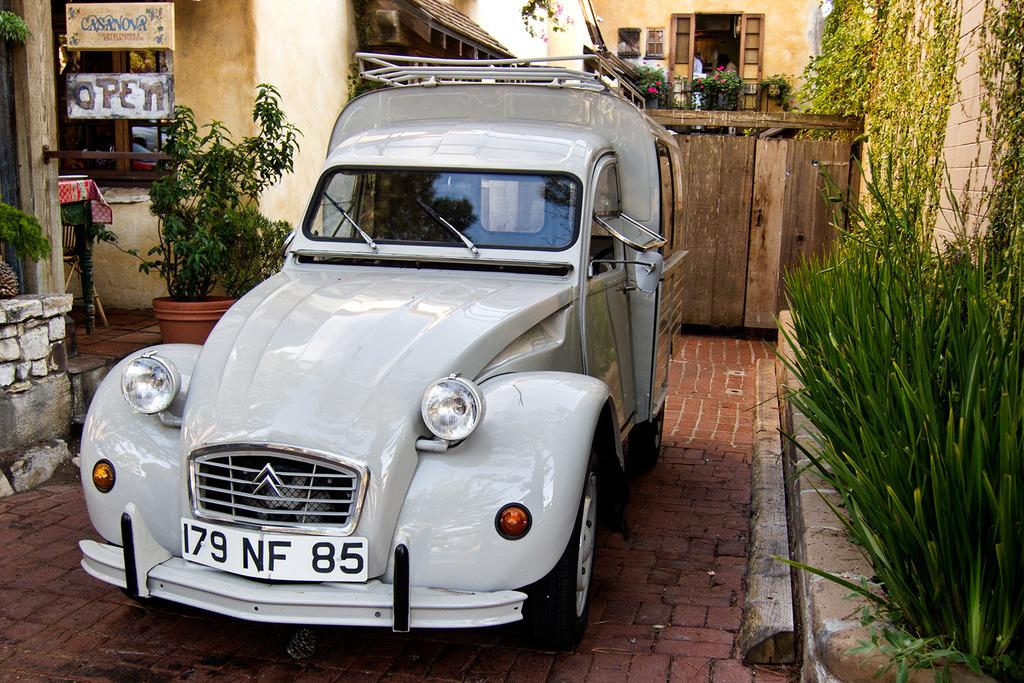What is the main subject of the image? The main subject of the image is a car. Can you describe the color of the car? The car is white in color. What type of vegetation is on the right side of the image? There are green plants on the right side of the image. Who is the creator of the playground visible in the image? There is no playground present in the image, so it is not possible to determine who the creator might be. 